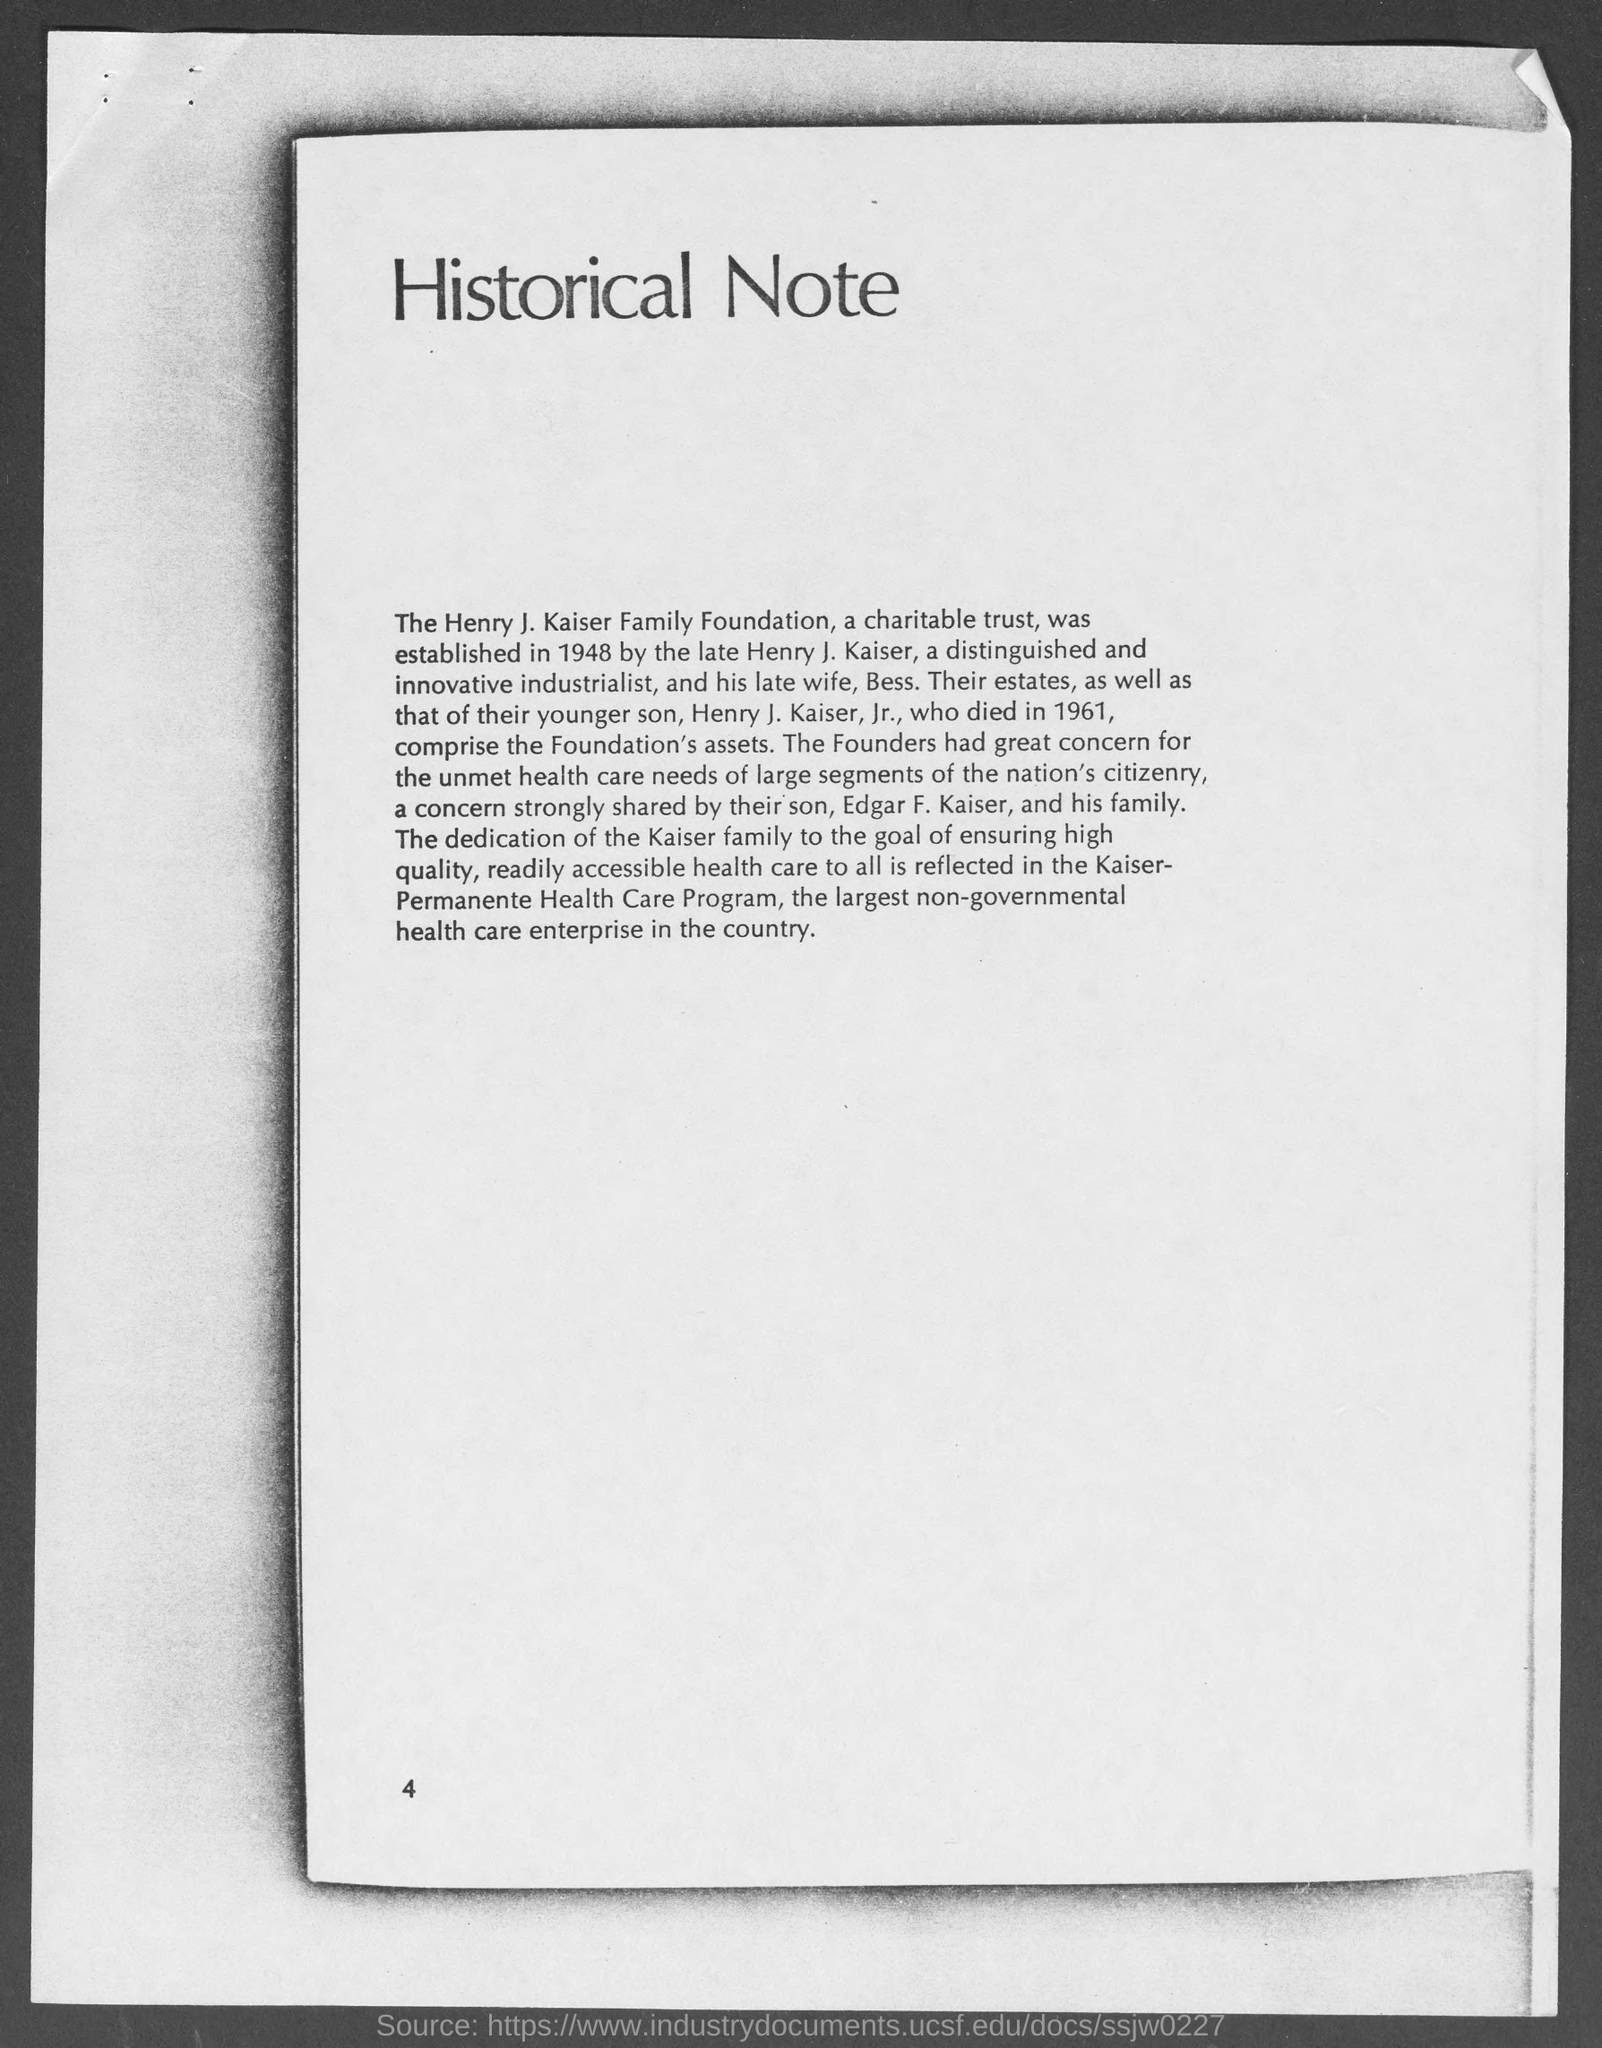Point out several critical features in this image. The page number at the bottom of the page is 4. 